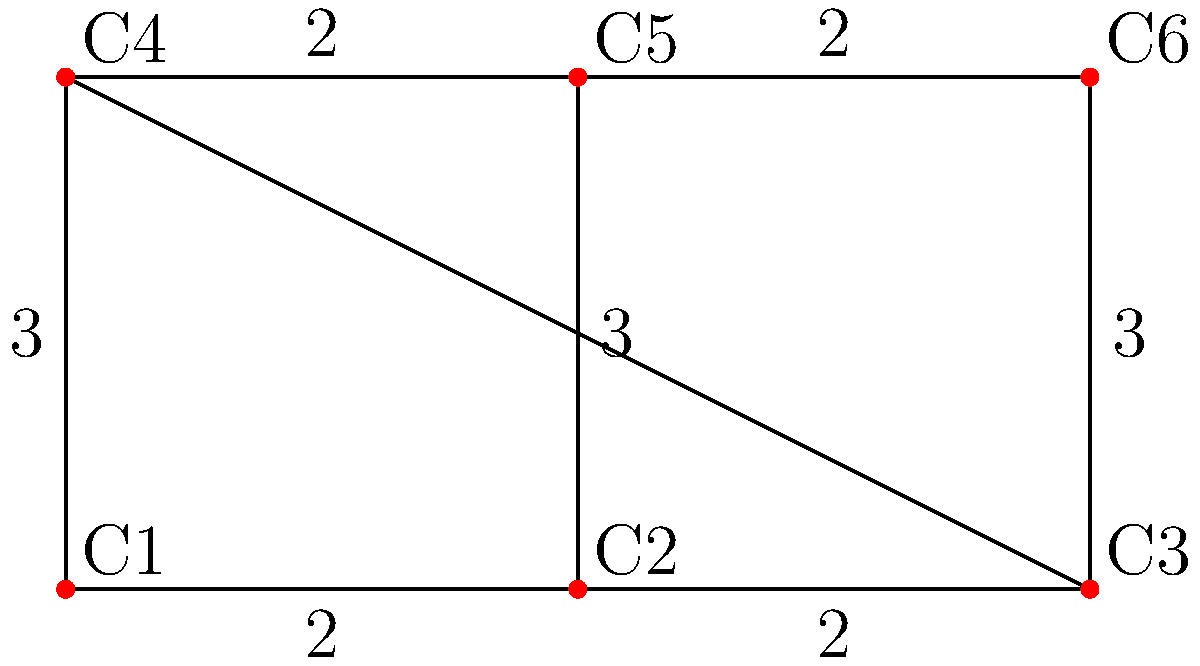As a suburban chicken breeder, you want to optimize the layout of your chicken coops. The graph represents possible connections between 6 coops (C1 to C6), where edges represent pathways and weights represent distances in meters. What is the minimum total length of pathways needed to connect all coops while ensuring that chickens can move between any two coops? To find the minimum total length of pathways that connect all coops while ensuring connectivity, we need to find the Minimum Spanning Tree (MST) of the given graph. We can use Kruskal's algorithm to solve this problem:

1. Sort all edges by weight (ascending order):
   {(C1-C2, 2), (C2-C3, 2), (C4-C5, 2), (C5-C6, 2), (C1-C4, 3), (C2-C5, 3), (C3-C6, 3)}

2. Initialize an empty set for the MST.

3. Iterate through the sorted edges:
   a. (C1-C2, 2): Add to MST. Total length = 2
   b. (C2-C3, 2): Add to MST. Total length = 4
   c. (C4-C5, 2): Add to MST. Total length = 6
   d. (C5-C6, 2): Add to MST. Total length = 8
   e. (C1-C4, 3): Add to MST. Total length = 11
   f. (C2-C5, 3): Skip (creates a cycle)
   g. (C3-C6, 3): Skip (creates a cycle)

4. The MST is complete with 5 edges, connecting all 6 coops.

The minimum total length of pathways needed is 11 meters.
Answer: 11 meters 